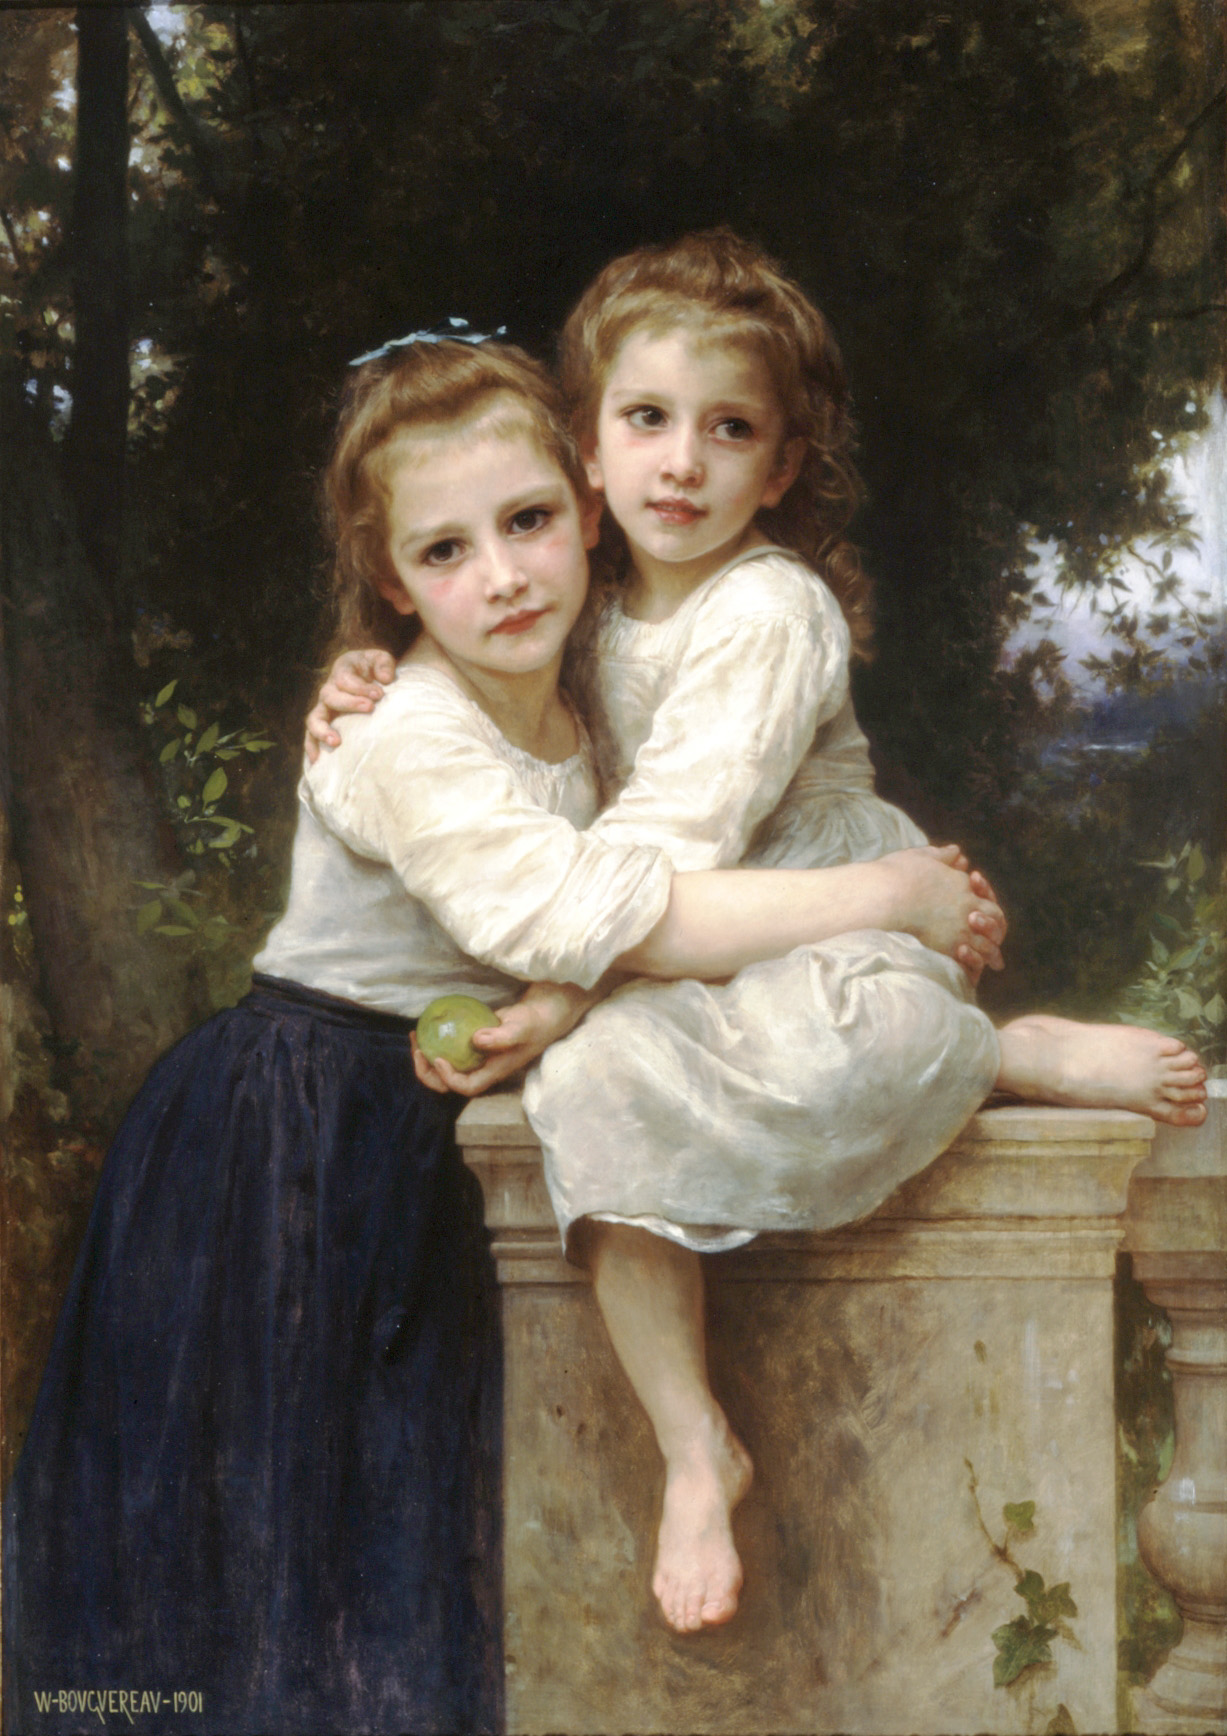How would you interpret the expressions on the girls' faces? The expressions on the girls' faces can be interpreted as a mixture of contemplative calm and sibling tenderness. The older girl's protective embrace, combined with their subtle, contented smiles, suggests a moment of genuine affection and connection, perhaps signifying the deep bond that can exist between siblings at rest in a quiet, safe environment. 